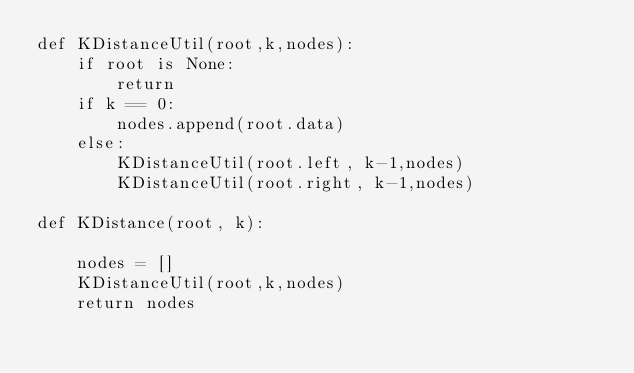<code> <loc_0><loc_0><loc_500><loc_500><_Python_>def KDistanceUtil(root,k,nodes):
    if root is None: 
        return 
    if k == 0: 
        nodes.append(root.data)
    else: 
        KDistanceUtil(root.left, k-1,nodes) 
        KDistanceUtil(root.right, k-1,nodes) 
        
def KDistance(root, k): 

    nodes = []
    KDistanceUtil(root,k,nodes)
    return nodes

</code> 